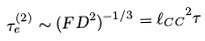<formula> <loc_0><loc_0><loc_500><loc_500>\tau _ { e } ^ { ( 2 ) } \sim ( F D ^ { 2 } ) ^ { - 1 / 3 } = { \ell _ { C C } } ^ { 2 } \tau</formula> 